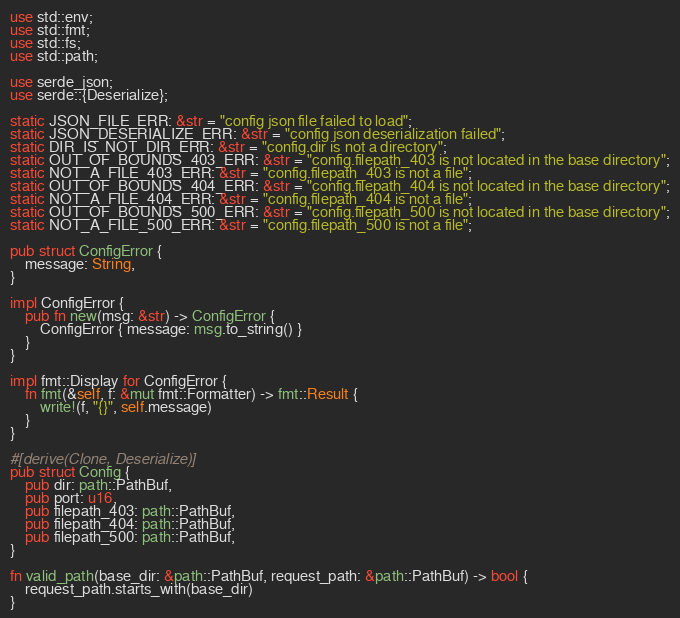Convert code to text. <code><loc_0><loc_0><loc_500><loc_500><_Rust_>use std::env;
use std::fmt;
use std::fs;
use std::path;

use serde_json;
use serde::{Deserialize};

static JSON_FILE_ERR: &str = "config json file failed to load";
static JSON_DESERIALIZE_ERR: &str = "config json deserialization failed";
static DIR_IS_NOT_DIR_ERR: &str = "config.dir is not a directory";
static OUT_OF_BOUNDS_403_ERR: &str = "config.filepath_403 is not located in the base directory";
static NOT_A_FILE_403_ERR: &str = "config.filepath_403 is not a file";
static OUT_OF_BOUNDS_404_ERR: &str = "config.filepath_404 is not located in the base directory";
static NOT_A_FILE_404_ERR: &str = "config.filepath_404 is not a file";
static OUT_OF_BOUNDS_500_ERR: &str = "config.filepath_500 is not located in the base directory";
static NOT_A_FILE_500_ERR: &str = "config.filepath_500 is not a file";

pub struct ConfigError {
    message: String,
}

impl ConfigError {
    pub fn new(msg: &str) -> ConfigError {
        ConfigError { message: msg.to_string() }
    }
}

impl fmt::Display for ConfigError {
    fn fmt(&self, f: &mut fmt::Formatter) -> fmt::Result {
        write!(f, "{}", self.message)
    }
}

#[derive(Clone, Deserialize)]
pub struct Config {
    pub dir: path::PathBuf,
    pub port: u16,
    pub filepath_403: path::PathBuf,
    pub filepath_404: path::PathBuf,
    pub filepath_500: path::PathBuf,
}

fn valid_path(base_dir: &path::PathBuf, request_path: &path::PathBuf) -> bool {
    request_path.starts_with(base_dir)
}
</code> 